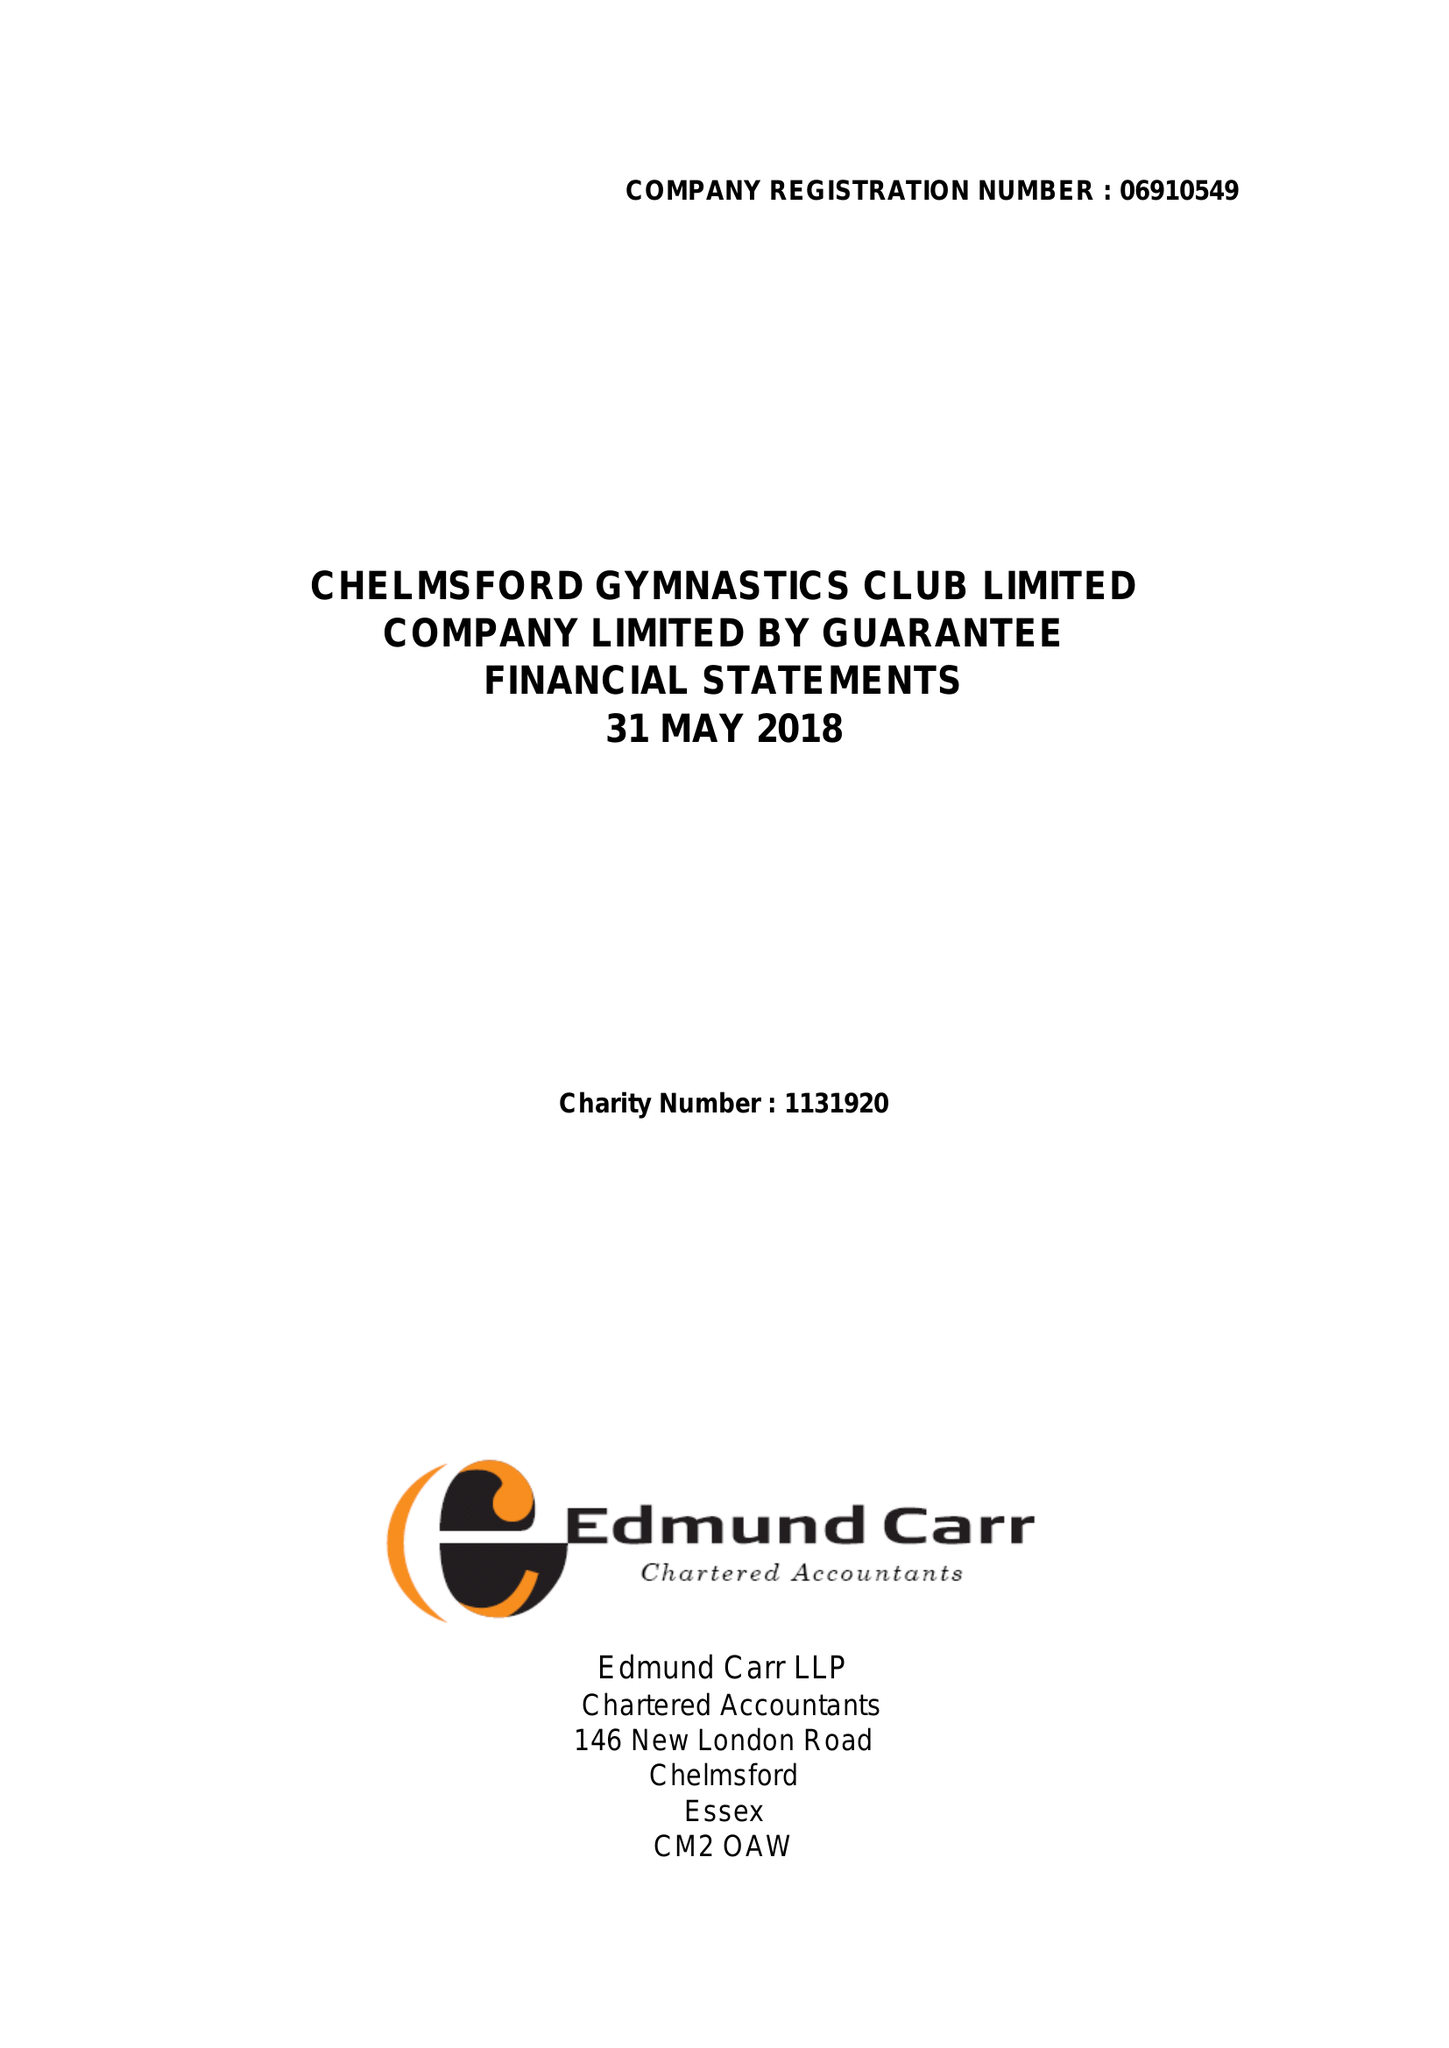What is the value for the address__post_town?
Answer the question using a single word or phrase. CHELMSFORD 